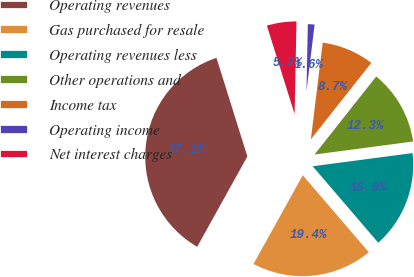<chart> <loc_0><loc_0><loc_500><loc_500><pie_chart><fcel>Operating revenues<fcel>Gas purchased for resale<fcel>Operating revenues less<fcel>Other operations and<fcel>Income tax<fcel>Operating income<fcel>Net interest charges<nl><fcel>37.1%<fcel>19.35%<fcel>15.81%<fcel>12.26%<fcel>8.71%<fcel>1.61%<fcel>5.16%<nl></chart> 